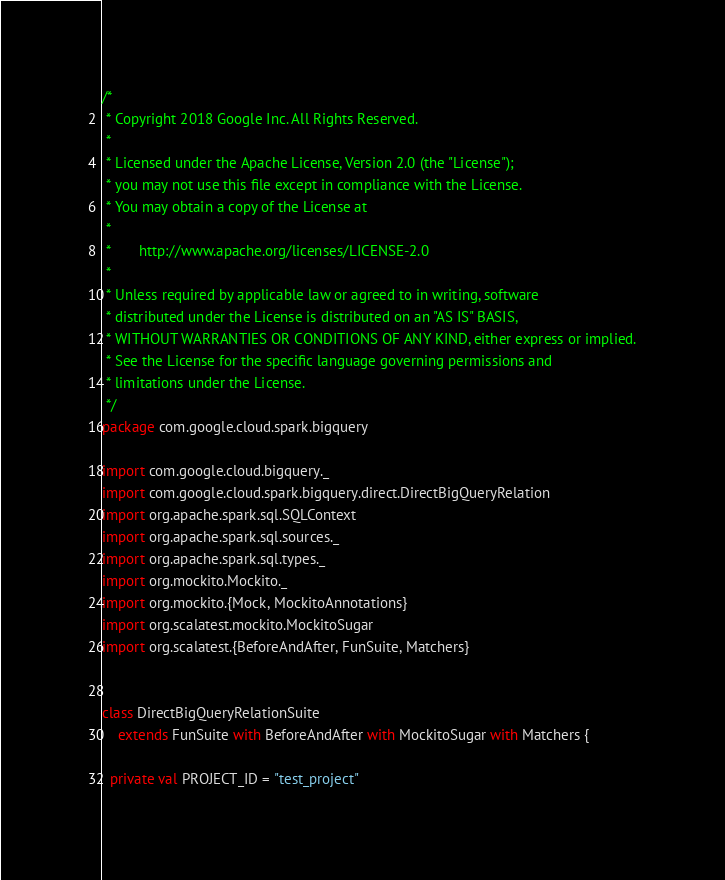Convert code to text. <code><loc_0><loc_0><loc_500><loc_500><_Scala_>/*
 * Copyright 2018 Google Inc. All Rights Reserved.
 *
 * Licensed under the Apache License, Version 2.0 (the "License");
 * you may not use this file except in compliance with the License.
 * You may obtain a copy of the License at
 *
 *       http://www.apache.org/licenses/LICENSE-2.0
 *
 * Unless required by applicable law or agreed to in writing, software
 * distributed under the License is distributed on an "AS IS" BASIS,
 * WITHOUT WARRANTIES OR CONDITIONS OF ANY KIND, either express or implied.
 * See the License for the specific language governing permissions and
 * limitations under the License.
 */
package com.google.cloud.spark.bigquery

import com.google.cloud.bigquery._
import com.google.cloud.spark.bigquery.direct.DirectBigQueryRelation
import org.apache.spark.sql.SQLContext
import org.apache.spark.sql.sources._
import org.apache.spark.sql.types._
import org.mockito.Mockito._
import org.mockito.{Mock, MockitoAnnotations}
import org.scalatest.mockito.MockitoSugar
import org.scalatest.{BeforeAndAfter, FunSuite, Matchers}


class DirectBigQueryRelationSuite
    extends FunSuite with BeforeAndAfter with MockitoSugar with Matchers {

  private val PROJECT_ID = "test_project"</code> 